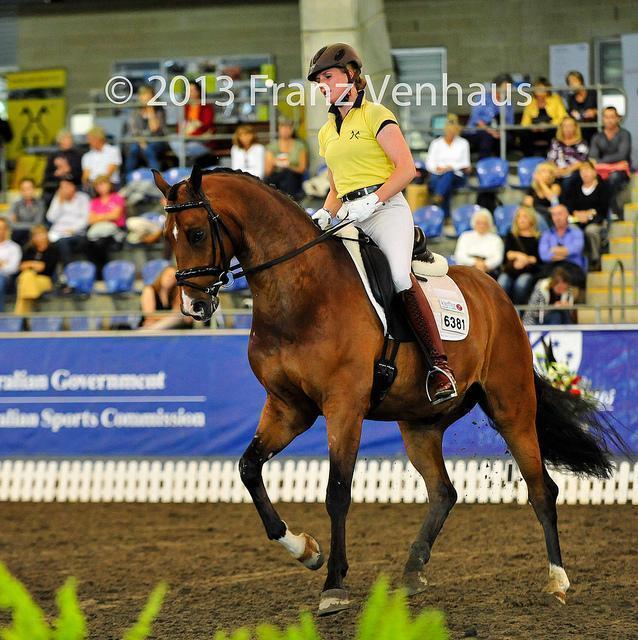What is the woman in yellow doing on the horse?
Indicate the correct choice and explain in the format: 'Answer: answer
Rationale: rationale.'
Options: Feeding, competing, learning, cleaning. Answer: competing.
Rationale: The woman competes. 